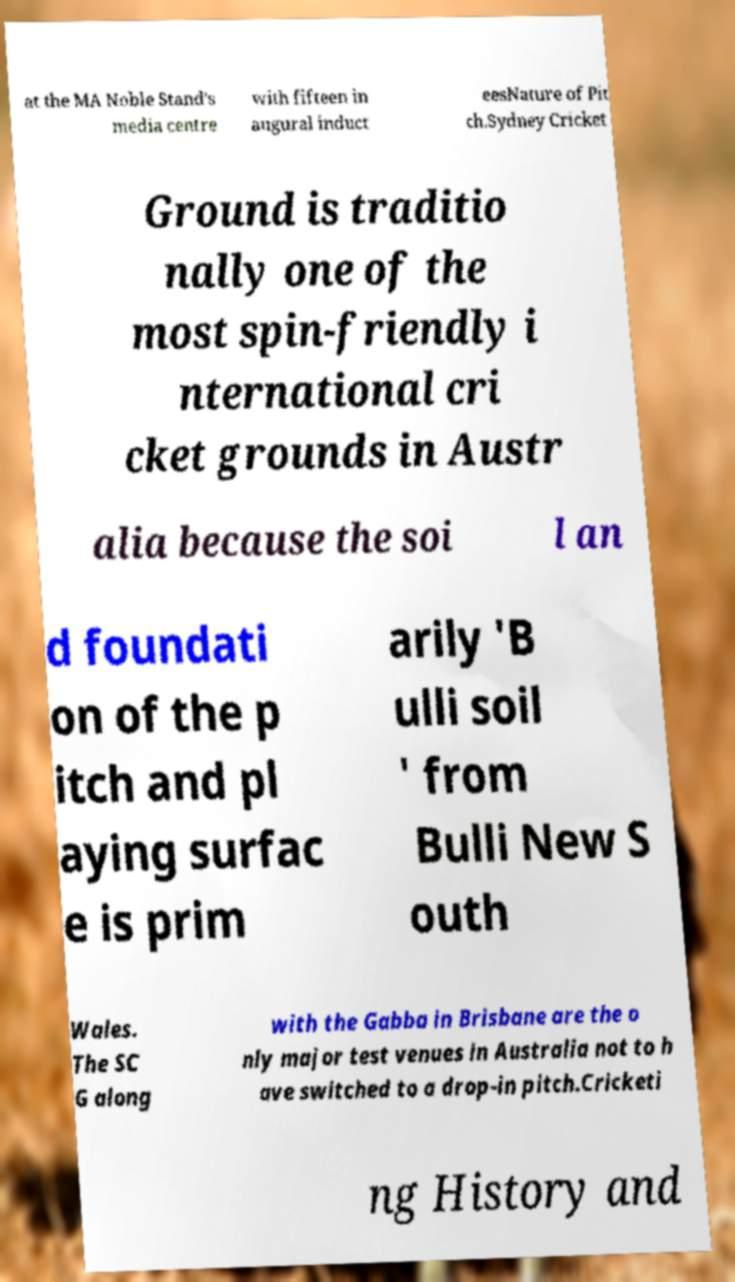Could you extract and type out the text from this image? at the MA Noble Stand's media centre with fifteen in augural induct eesNature of Pit ch.Sydney Cricket Ground is traditio nally one of the most spin-friendly i nternational cri cket grounds in Austr alia because the soi l an d foundati on of the p itch and pl aying surfac e is prim arily 'B ulli soil ' from Bulli New S outh Wales. The SC G along with the Gabba in Brisbane are the o nly major test venues in Australia not to h ave switched to a drop-in pitch.Cricketi ng History and 